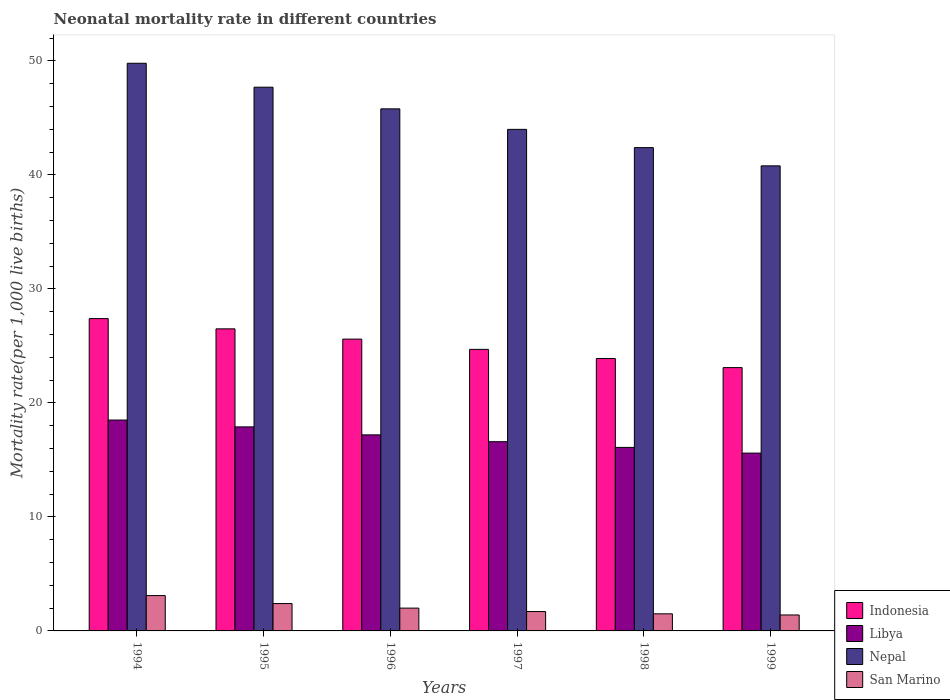How many different coloured bars are there?
Your response must be concise. 4. Are the number of bars per tick equal to the number of legend labels?
Ensure brevity in your answer.  Yes. How many bars are there on the 3rd tick from the left?
Keep it short and to the point. 4. What is the label of the 3rd group of bars from the left?
Your response must be concise. 1996. In how many cases, is the number of bars for a given year not equal to the number of legend labels?
Provide a succinct answer. 0. What is the neonatal mortality rate in Indonesia in 1998?
Offer a very short reply. 23.9. In which year was the neonatal mortality rate in Nepal maximum?
Your response must be concise. 1994. What is the total neonatal mortality rate in Indonesia in the graph?
Your answer should be very brief. 151.2. What is the difference between the neonatal mortality rate in San Marino in 1994 and that in 1995?
Keep it short and to the point. 0.7. What is the difference between the neonatal mortality rate in San Marino in 1997 and the neonatal mortality rate in Indonesia in 1999?
Offer a terse response. -21.4. What is the average neonatal mortality rate in San Marino per year?
Ensure brevity in your answer.  2.02. In the year 1998, what is the difference between the neonatal mortality rate in San Marino and neonatal mortality rate in Libya?
Your answer should be compact. -14.6. In how many years, is the neonatal mortality rate in Nepal greater than 44?
Give a very brief answer. 3. What is the ratio of the neonatal mortality rate in Nepal in 1994 to that in 1996?
Provide a short and direct response. 1.09. What is the difference between the highest and the second highest neonatal mortality rate in Indonesia?
Provide a succinct answer. 0.9. What is the difference between the highest and the lowest neonatal mortality rate in San Marino?
Offer a terse response. 1.7. What does the 4th bar from the left in 1998 represents?
Provide a short and direct response. San Marino. Is it the case that in every year, the sum of the neonatal mortality rate in Nepal and neonatal mortality rate in Indonesia is greater than the neonatal mortality rate in Libya?
Keep it short and to the point. Yes. Are all the bars in the graph horizontal?
Your answer should be very brief. No. Does the graph contain grids?
Provide a short and direct response. No. Where does the legend appear in the graph?
Ensure brevity in your answer.  Bottom right. What is the title of the graph?
Provide a short and direct response. Neonatal mortality rate in different countries. Does "Switzerland" appear as one of the legend labels in the graph?
Offer a very short reply. No. What is the label or title of the X-axis?
Offer a very short reply. Years. What is the label or title of the Y-axis?
Provide a succinct answer. Mortality rate(per 1,0 live births). What is the Mortality rate(per 1,000 live births) of Indonesia in 1994?
Your answer should be very brief. 27.4. What is the Mortality rate(per 1,000 live births) of Nepal in 1994?
Your response must be concise. 49.8. What is the Mortality rate(per 1,000 live births) of Libya in 1995?
Provide a succinct answer. 17.9. What is the Mortality rate(per 1,000 live births) in Nepal in 1995?
Provide a succinct answer. 47.7. What is the Mortality rate(per 1,000 live births) of San Marino in 1995?
Make the answer very short. 2.4. What is the Mortality rate(per 1,000 live births) in Indonesia in 1996?
Your answer should be very brief. 25.6. What is the Mortality rate(per 1,000 live births) of Libya in 1996?
Give a very brief answer. 17.2. What is the Mortality rate(per 1,000 live births) of Nepal in 1996?
Give a very brief answer. 45.8. What is the Mortality rate(per 1,000 live births) of San Marino in 1996?
Offer a terse response. 2. What is the Mortality rate(per 1,000 live births) in Indonesia in 1997?
Keep it short and to the point. 24.7. What is the Mortality rate(per 1,000 live births) in Nepal in 1997?
Your response must be concise. 44. What is the Mortality rate(per 1,000 live births) in San Marino in 1997?
Provide a succinct answer. 1.7. What is the Mortality rate(per 1,000 live births) of Indonesia in 1998?
Your response must be concise. 23.9. What is the Mortality rate(per 1,000 live births) in Nepal in 1998?
Give a very brief answer. 42.4. What is the Mortality rate(per 1,000 live births) in Indonesia in 1999?
Provide a short and direct response. 23.1. What is the Mortality rate(per 1,000 live births) of Libya in 1999?
Make the answer very short. 15.6. What is the Mortality rate(per 1,000 live births) of Nepal in 1999?
Ensure brevity in your answer.  40.8. Across all years, what is the maximum Mortality rate(per 1,000 live births) of Indonesia?
Offer a very short reply. 27.4. Across all years, what is the maximum Mortality rate(per 1,000 live births) of Libya?
Offer a very short reply. 18.5. Across all years, what is the maximum Mortality rate(per 1,000 live births) in Nepal?
Offer a very short reply. 49.8. Across all years, what is the minimum Mortality rate(per 1,000 live births) in Indonesia?
Ensure brevity in your answer.  23.1. Across all years, what is the minimum Mortality rate(per 1,000 live births) of Nepal?
Your response must be concise. 40.8. What is the total Mortality rate(per 1,000 live births) of Indonesia in the graph?
Provide a succinct answer. 151.2. What is the total Mortality rate(per 1,000 live births) of Libya in the graph?
Ensure brevity in your answer.  101.9. What is the total Mortality rate(per 1,000 live births) in Nepal in the graph?
Offer a very short reply. 270.5. What is the difference between the Mortality rate(per 1,000 live births) of Indonesia in 1994 and that in 1995?
Provide a short and direct response. 0.9. What is the difference between the Mortality rate(per 1,000 live births) of Libya in 1994 and that in 1995?
Offer a terse response. 0.6. What is the difference between the Mortality rate(per 1,000 live births) in San Marino in 1994 and that in 1996?
Offer a very short reply. 1.1. What is the difference between the Mortality rate(per 1,000 live births) of Indonesia in 1994 and that in 1997?
Your answer should be compact. 2.7. What is the difference between the Mortality rate(per 1,000 live births) of Nepal in 1994 and that in 1997?
Give a very brief answer. 5.8. What is the difference between the Mortality rate(per 1,000 live births) in Indonesia in 1994 and that in 1998?
Offer a very short reply. 3.5. What is the difference between the Mortality rate(per 1,000 live births) of Nepal in 1994 and that in 1998?
Your answer should be compact. 7.4. What is the difference between the Mortality rate(per 1,000 live births) of Libya in 1995 and that in 1996?
Provide a short and direct response. 0.7. What is the difference between the Mortality rate(per 1,000 live births) in Indonesia in 1995 and that in 1997?
Provide a short and direct response. 1.8. What is the difference between the Mortality rate(per 1,000 live births) in Indonesia in 1995 and that in 1998?
Your answer should be very brief. 2.6. What is the difference between the Mortality rate(per 1,000 live births) of Nepal in 1995 and that in 1998?
Keep it short and to the point. 5.3. What is the difference between the Mortality rate(per 1,000 live births) of San Marino in 1995 and that in 1998?
Provide a succinct answer. 0.9. What is the difference between the Mortality rate(per 1,000 live births) of Indonesia in 1995 and that in 1999?
Offer a terse response. 3.4. What is the difference between the Mortality rate(per 1,000 live births) of San Marino in 1995 and that in 1999?
Provide a succinct answer. 1. What is the difference between the Mortality rate(per 1,000 live births) in Libya in 1996 and that in 1997?
Offer a very short reply. 0.6. What is the difference between the Mortality rate(per 1,000 live births) of San Marino in 1996 and that in 1997?
Ensure brevity in your answer.  0.3. What is the difference between the Mortality rate(per 1,000 live births) of Indonesia in 1996 and that in 1998?
Your response must be concise. 1.7. What is the difference between the Mortality rate(per 1,000 live births) of Nepal in 1996 and that in 1998?
Ensure brevity in your answer.  3.4. What is the difference between the Mortality rate(per 1,000 live births) in San Marino in 1996 and that in 1998?
Your answer should be compact. 0.5. What is the difference between the Mortality rate(per 1,000 live births) in Indonesia in 1996 and that in 1999?
Ensure brevity in your answer.  2.5. What is the difference between the Mortality rate(per 1,000 live births) of Libya in 1996 and that in 1999?
Ensure brevity in your answer.  1.6. What is the difference between the Mortality rate(per 1,000 live births) of San Marino in 1996 and that in 1999?
Provide a short and direct response. 0.6. What is the difference between the Mortality rate(per 1,000 live births) of Libya in 1997 and that in 1998?
Offer a terse response. 0.5. What is the difference between the Mortality rate(per 1,000 live births) of Nepal in 1997 and that in 1998?
Make the answer very short. 1.6. What is the difference between the Mortality rate(per 1,000 live births) in Libya in 1997 and that in 1999?
Offer a terse response. 1. What is the difference between the Mortality rate(per 1,000 live births) in Nepal in 1997 and that in 1999?
Give a very brief answer. 3.2. What is the difference between the Mortality rate(per 1,000 live births) of San Marino in 1997 and that in 1999?
Your response must be concise. 0.3. What is the difference between the Mortality rate(per 1,000 live births) of Indonesia in 1998 and that in 1999?
Your answer should be compact. 0.8. What is the difference between the Mortality rate(per 1,000 live births) in Nepal in 1998 and that in 1999?
Ensure brevity in your answer.  1.6. What is the difference between the Mortality rate(per 1,000 live births) in San Marino in 1998 and that in 1999?
Provide a succinct answer. 0.1. What is the difference between the Mortality rate(per 1,000 live births) of Indonesia in 1994 and the Mortality rate(per 1,000 live births) of Libya in 1995?
Your response must be concise. 9.5. What is the difference between the Mortality rate(per 1,000 live births) of Indonesia in 1994 and the Mortality rate(per 1,000 live births) of Nepal in 1995?
Provide a short and direct response. -20.3. What is the difference between the Mortality rate(per 1,000 live births) in Indonesia in 1994 and the Mortality rate(per 1,000 live births) in San Marino in 1995?
Offer a very short reply. 25. What is the difference between the Mortality rate(per 1,000 live births) in Libya in 1994 and the Mortality rate(per 1,000 live births) in Nepal in 1995?
Ensure brevity in your answer.  -29.2. What is the difference between the Mortality rate(per 1,000 live births) in Nepal in 1994 and the Mortality rate(per 1,000 live births) in San Marino in 1995?
Make the answer very short. 47.4. What is the difference between the Mortality rate(per 1,000 live births) in Indonesia in 1994 and the Mortality rate(per 1,000 live births) in Nepal in 1996?
Offer a terse response. -18.4. What is the difference between the Mortality rate(per 1,000 live births) in Indonesia in 1994 and the Mortality rate(per 1,000 live births) in San Marino in 1996?
Your answer should be compact. 25.4. What is the difference between the Mortality rate(per 1,000 live births) in Libya in 1994 and the Mortality rate(per 1,000 live births) in Nepal in 1996?
Ensure brevity in your answer.  -27.3. What is the difference between the Mortality rate(per 1,000 live births) of Nepal in 1994 and the Mortality rate(per 1,000 live births) of San Marino in 1996?
Make the answer very short. 47.8. What is the difference between the Mortality rate(per 1,000 live births) in Indonesia in 1994 and the Mortality rate(per 1,000 live births) in Nepal in 1997?
Provide a short and direct response. -16.6. What is the difference between the Mortality rate(per 1,000 live births) in Indonesia in 1994 and the Mortality rate(per 1,000 live births) in San Marino in 1997?
Make the answer very short. 25.7. What is the difference between the Mortality rate(per 1,000 live births) of Libya in 1994 and the Mortality rate(per 1,000 live births) of Nepal in 1997?
Provide a short and direct response. -25.5. What is the difference between the Mortality rate(per 1,000 live births) of Nepal in 1994 and the Mortality rate(per 1,000 live births) of San Marino in 1997?
Give a very brief answer. 48.1. What is the difference between the Mortality rate(per 1,000 live births) of Indonesia in 1994 and the Mortality rate(per 1,000 live births) of Libya in 1998?
Provide a succinct answer. 11.3. What is the difference between the Mortality rate(per 1,000 live births) of Indonesia in 1994 and the Mortality rate(per 1,000 live births) of Nepal in 1998?
Provide a succinct answer. -15. What is the difference between the Mortality rate(per 1,000 live births) of Indonesia in 1994 and the Mortality rate(per 1,000 live births) of San Marino in 1998?
Make the answer very short. 25.9. What is the difference between the Mortality rate(per 1,000 live births) in Libya in 1994 and the Mortality rate(per 1,000 live births) in Nepal in 1998?
Keep it short and to the point. -23.9. What is the difference between the Mortality rate(per 1,000 live births) in Nepal in 1994 and the Mortality rate(per 1,000 live births) in San Marino in 1998?
Keep it short and to the point. 48.3. What is the difference between the Mortality rate(per 1,000 live births) of Indonesia in 1994 and the Mortality rate(per 1,000 live births) of Libya in 1999?
Your response must be concise. 11.8. What is the difference between the Mortality rate(per 1,000 live births) of Libya in 1994 and the Mortality rate(per 1,000 live births) of Nepal in 1999?
Your answer should be very brief. -22.3. What is the difference between the Mortality rate(per 1,000 live births) of Libya in 1994 and the Mortality rate(per 1,000 live births) of San Marino in 1999?
Give a very brief answer. 17.1. What is the difference between the Mortality rate(per 1,000 live births) in Nepal in 1994 and the Mortality rate(per 1,000 live births) in San Marino in 1999?
Make the answer very short. 48.4. What is the difference between the Mortality rate(per 1,000 live births) in Indonesia in 1995 and the Mortality rate(per 1,000 live births) in Libya in 1996?
Ensure brevity in your answer.  9.3. What is the difference between the Mortality rate(per 1,000 live births) in Indonesia in 1995 and the Mortality rate(per 1,000 live births) in Nepal in 1996?
Keep it short and to the point. -19.3. What is the difference between the Mortality rate(per 1,000 live births) of Libya in 1995 and the Mortality rate(per 1,000 live births) of Nepal in 1996?
Provide a short and direct response. -27.9. What is the difference between the Mortality rate(per 1,000 live births) in Libya in 1995 and the Mortality rate(per 1,000 live births) in San Marino in 1996?
Offer a terse response. 15.9. What is the difference between the Mortality rate(per 1,000 live births) in Nepal in 1995 and the Mortality rate(per 1,000 live births) in San Marino in 1996?
Offer a terse response. 45.7. What is the difference between the Mortality rate(per 1,000 live births) in Indonesia in 1995 and the Mortality rate(per 1,000 live births) in Nepal in 1997?
Keep it short and to the point. -17.5. What is the difference between the Mortality rate(per 1,000 live births) in Indonesia in 1995 and the Mortality rate(per 1,000 live births) in San Marino in 1997?
Your answer should be compact. 24.8. What is the difference between the Mortality rate(per 1,000 live births) in Libya in 1995 and the Mortality rate(per 1,000 live births) in Nepal in 1997?
Your answer should be compact. -26.1. What is the difference between the Mortality rate(per 1,000 live births) in Nepal in 1995 and the Mortality rate(per 1,000 live births) in San Marino in 1997?
Offer a terse response. 46. What is the difference between the Mortality rate(per 1,000 live births) of Indonesia in 1995 and the Mortality rate(per 1,000 live births) of Nepal in 1998?
Give a very brief answer. -15.9. What is the difference between the Mortality rate(per 1,000 live births) in Indonesia in 1995 and the Mortality rate(per 1,000 live births) in San Marino in 1998?
Provide a short and direct response. 25. What is the difference between the Mortality rate(per 1,000 live births) of Libya in 1995 and the Mortality rate(per 1,000 live births) of Nepal in 1998?
Ensure brevity in your answer.  -24.5. What is the difference between the Mortality rate(per 1,000 live births) of Libya in 1995 and the Mortality rate(per 1,000 live births) of San Marino in 1998?
Your response must be concise. 16.4. What is the difference between the Mortality rate(per 1,000 live births) in Nepal in 1995 and the Mortality rate(per 1,000 live births) in San Marino in 1998?
Offer a very short reply. 46.2. What is the difference between the Mortality rate(per 1,000 live births) of Indonesia in 1995 and the Mortality rate(per 1,000 live births) of Nepal in 1999?
Ensure brevity in your answer.  -14.3. What is the difference between the Mortality rate(per 1,000 live births) of Indonesia in 1995 and the Mortality rate(per 1,000 live births) of San Marino in 1999?
Provide a succinct answer. 25.1. What is the difference between the Mortality rate(per 1,000 live births) of Libya in 1995 and the Mortality rate(per 1,000 live births) of Nepal in 1999?
Keep it short and to the point. -22.9. What is the difference between the Mortality rate(per 1,000 live births) in Libya in 1995 and the Mortality rate(per 1,000 live births) in San Marino in 1999?
Provide a short and direct response. 16.5. What is the difference between the Mortality rate(per 1,000 live births) in Nepal in 1995 and the Mortality rate(per 1,000 live births) in San Marino in 1999?
Give a very brief answer. 46.3. What is the difference between the Mortality rate(per 1,000 live births) in Indonesia in 1996 and the Mortality rate(per 1,000 live births) in Nepal in 1997?
Your response must be concise. -18.4. What is the difference between the Mortality rate(per 1,000 live births) in Indonesia in 1996 and the Mortality rate(per 1,000 live births) in San Marino in 1997?
Your response must be concise. 23.9. What is the difference between the Mortality rate(per 1,000 live births) in Libya in 1996 and the Mortality rate(per 1,000 live births) in Nepal in 1997?
Your answer should be very brief. -26.8. What is the difference between the Mortality rate(per 1,000 live births) of Libya in 1996 and the Mortality rate(per 1,000 live births) of San Marino in 1997?
Your response must be concise. 15.5. What is the difference between the Mortality rate(per 1,000 live births) in Nepal in 1996 and the Mortality rate(per 1,000 live births) in San Marino in 1997?
Your answer should be compact. 44.1. What is the difference between the Mortality rate(per 1,000 live births) in Indonesia in 1996 and the Mortality rate(per 1,000 live births) in Nepal in 1998?
Offer a very short reply. -16.8. What is the difference between the Mortality rate(per 1,000 live births) of Indonesia in 1996 and the Mortality rate(per 1,000 live births) of San Marino in 1998?
Provide a short and direct response. 24.1. What is the difference between the Mortality rate(per 1,000 live births) in Libya in 1996 and the Mortality rate(per 1,000 live births) in Nepal in 1998?
Provide a succinct answer. -25.2. What is the difference between the Mortality rate(per 1,000 live births) in Libya in 1996 and the Mortality rate(per 1,000 live births) in San Marino in 1998?
Provide a succinct answer. 15.7. What is the difference between the Mortality rate(per 1,000 live births) of Nepal in 1996 and the Mortality rate(per 1,000 live births) of San Marino in 1998?
Give a very brief answer. 44.3. What is the difference between the Mortality rate(per 1,000 live births) of Indonesia in 1996 and the Mortality rate(per 1,000 live births) of Libya in 1999?
Offer a very short reply. 10. What is the difference between the Mortality rate(per 1,000 live births) of Indonesia in 1996 and the Mortality rate(per 1,000 live births) of Nepal in 1999?
Keep it short and to the point. -15.2. What is the difference between the Mortality rate(per 1,000 live births) in Indonesia in 1996 and the Mortality rate(per 1,000 live births) in San Marino in 1999?
Ensure brevity in your answer.  24.2. What is the difference between the Mortality rate(per 1,000 live births) of Libya in 1996 and the Mortality rate(per 1,000 live births) of Nepal in 1999?
Keep it short and to the point. -23.6. What is the difference between the Mortality rate(per 1,000 live births) in Libya in 1996 and the Mortality rate(per 1,000 live births) in San Marino in 1999?
Provide a succinct answer. 15.8. What is the difference between the Mortality rate(per 1,000 live births) in Nepal in 1996 and the Mortality rate(per 1,000 live births) in San Marino in 1999?
Your answer should be compact. 44.4. What is the difference between the Mortality rate(per 1,000 live births) in Indonesia in 1997 and the Mortality rate(per 1,000 live births) in Libya in 1998?
Offer a very short reply. 8.6. What is the difference between the Mortality rate(per 1,000 live births) of Indonesia in 1997 and the Mortality rate(per 1,000 live births) of Nepal in 1998?
Make the answer very short. -17.7. What is the difference between the Mortality rate(per 1,000 live births) of Indonesia in 1997 and the Mortality rate(per 1,000 live births) of San Marino in 1998?
Your answer should be very brief. 23.2. What is the difference between the Mortality rate(per 1,000 live births) of Libya in 1997 and the Mortality rate(per 1,000 live births) of Nepal in 1998?
Provide a succinct answer. -25.8. What is the difference between the Mortality rate(per 1,000 live births) of Libya in 1997 and the Mortality rate(per 1,000 live births) of San Marino in 1998?
Offer a terse response. 15.1. What is the difference between the Mortality rate(per 1,000 live births) in Nepal in 1997 and the Mortality rate(per 1,000 live births) in San Marino in 1998?
Provide a short and direct response. 42.5. What is the difference between the Mortality rate(per 1,000 live births) in Indonesia in 1997 and the Mortality rate(per 1,000 live births) in Nepal in 1999?
Provide a short and direct response. -16.1. What is the difference between the Mortality rate(per 1,000 live births) in Indonesia in 1997 and the Mortality rate(per 1,000 live births) in San Marino in 1999?
Give a very brief answer. 23.3. What is the difference between the Mortality rate(per 1,000 live births) in Libya in 1997 and the Mortality rate(per 1,000 live births) in Nepal in 1999?
Your response must be concise. -24.2. What is the difference between the Mortality rate(per 1,000 live births) in Nepal in 1997 and the Mortality rate(per 1,000 live births) in San Marino in 1999?
Offer a very short reply. 42.6. What is the difference between the Mortality rate(per 1,000 live births) in Indonesia in 1998 and the Mortality rate(per 1,000 live births) in Nepal in 1999?
Give a very brief answer. -16.9. What is the difference between the Mortality rate(per 1,000 live births) of Indonesia in 1998 and the Mortality rate(per 1,000 live births) of San Marino in 1999?
Offer a very short reply. 22.5. What is the difference between the Mortality rate(per 1,000 live births) in Libya in 1998 and the Mortality rate(per 1,000 live births) in Nepal in 1999?
Provide a short and direct response. -24.7. What is the difference between the Mortality rate(per 1,000 live births) in Libya in 1998 and the Mortality rate(per 1,000 live births) in San Marino in 1999?
Offer a very short reply. 14.7. What is the difference between the Mortality rate(per 1,000 live births) of Nepal in 1998 and the Mortality rate(per 1,000 live births) of San Marino in 1999?
Ensure brevity in your answer.  41. What is the average Mortality rate(per 1,000 live births) of Indonesia per year?
Provide a succinct answer. 25.2. What is the average Mortality rate(per 1,000 live births) in Libya per year?
Give a very brief answer. 16.98. What is the average Mortality rate(per 1,000 live births) of Nepal per year?
Your answer should be compact. 45.08. What is the average Mortality rate(per 1,000 live births) in San Marino per year?
Offer a very short reply. 2.02. In the year 1994, what is the difference between the Mortality rate(per 1,000 live births) of Indonesia and Mortality rate(per 1,000 live births) of Nepal?
Provide a short and direct response. -22.4. In the year 1994, what is the difference between the Mortality rate(per 1,000 live births) of Indonesia and Mortality rate(per 1,000 live births) of San Marino?
Provide a short and direct response. 24.3. In the year 1994, what is the difference between the Mortality rate(per 1,000 live births) in Libya and Mortality rate(per 1,000 live births) in Nepal?
Offer a very short reply. -31.3. In the year 1994, what is the difference between the Mortality rate(per 1,000 live births) of Libya and Mortality rate(per 1,000 live births) of San Marino?
Offer a very short reply. 15.4. In the year 1994, what is the difference between the Mortality rate(per 1,000 live births) in Nepal and Mortality rate(per 1,000 live births) in San Marino?
Offer a very short reply. 46.7. In the year 1995, what is the difference between the Mortality rate(per 1,000 live births) in Indonesia and Mortality rate(per 1,000 live births) in Nepal?
Offer a terse response. -21.2. In the year 1995, what is the difference between the Mortality rate(per 1,000 live births) of Indonesia and Mortality rate(per 1,000 live births) of San Marino?
Offer a terse response. 24.1. In the year 1995, what is the difference between the Mortality rate(per 1,000 live births) in Libya and Mortality rate(per 1,000 live births) in Nepal?
Offer a terse response. -29.8. In the year 1995, what is the difference between the Mortality rate(per 1,000 live births) of Nepal and Mortality rate(per 1,000 live births) of San Marino?
Ensure brevity in your answer.  45.3. In the year 1996, what is the difference between the Mortality rate(per 1,000 live births) of Indonesia and Mortality rate(per 1,000 live births) of Libya?
Your response must be concise. 8.4. In the year 1996, what is the difference between the Mortality rate(per 1,000 live births) of Indonesia and Mortality rate(per 1,000 live births) of Nepal?
Offer a terse response. -20.2. In the year 1996, what is the difference between the Mortality rate(per 1,000 live births) of Indonesia and Mortality rate(per 1,000 live births) of San Marino?
Your answer should be compact. 23.6. In the year 1996, what is the difference between the Mortality rate(per 1,000 live births) of Libya and Mortality rate(per 1,000 live births) of Nepal?
Make the answer very short. -28.6. In the year 1996, what is the difference between the Mortality rate(per 1,000 live births) of Nepal and Mortality rate(per 1,000 live births) of San Marino?
Your response must be concise. 43.8. In the year 1997, what is the difference between the Mortality rate(per 1,000 live births) in Indonesia and Mortality rate(per 1,000 live births) in Libya?
Give a very brief answer. 8.1. In the year 1997, what is the difference between the Mortality rate(per 1,000 live births) in Indonesia and Mortality rate(per 1,000 live births) in Nepal?
Offer a terse response. -19.3. In the year 1997, what is the difference between the Mortality rate(per 1,000 live births) in Indonesia and Mortality rate(per 1,000 live births) in San Marino?
Offer a terse response. 23. In the year 1997, what is the difference between the Mortality rate(per 1,000 live births) in Libya and Mortality rate(per 1,000 live births) in Nepal?
Your answer should be compact. -27.4. In the year 1997, what is the difference between the Mortality rate(per 1,000 live births) in Libya and Mortality rate(per 1,000 live births) in San Marino?
Provide a succinct answer. 14.9. In the year 1997, what is the difference between the Mortality rate(per 1,000 live births) in Nepal and Mortality rate(per 1,000 live births) in San Marino?
Offer a terse response. 42.3. In the year 1998, what is the difference between the Mortality rate(per 1,000 live births) of Indonesia and Mortality rate(per 1,000 live births) of Nepal?
Your answer should be compact. -18.5. In the year 1998, what is the difference between the Mortality rate(per 1,000 live births) of Indonesia and Mortality rate(per 1,000 live births) of San Marino?
Provide a succinct answer. 22.4. In the year 1998, what is the difference between the Mortality rate(per 1,000 live births) in Libya and Mortality rate(per 1,000 live births) in Nepal?
Your answer should be compact. -26.3. In the year 1998, what is the difference between the Mortality rate(per 1,000 live births) in Nepal and Mortality rate(per 1,000 live births) in San Marino?
Give a very brief answer. 40.9. In the year 1999, what is the difference between the Mortality rate(per 1,000 live births) of Indonesia and Mortality rate(per 1,000 live births) of Libya?
Provide a short and direct response. 7.5. In the year 1999, what is the difference between the Mortality rate(per 1,000 live births) of Indonesia and Mortality rate(per 1,000 live births) of Nepal?
Your answer should be compact. -17.7. In the year 1999, what is the difference between the Mortality rate(per 1,000 live births) in Indonesia and Mortality rate(per 1,000 live births) in San Marino?
Ensure brevity in your answer.  21.7. In the year 1999, what is the difference between the Mortality rate(per 1,000 live births) of Libya and Mortality rate(per 1,000 live births) of Nepal?
Provide a short and direct response. -25.2. In the year 1999, what is the difference between the Mortality rate(per 1,000 live births) in Nepal and Mortality rate(per 1,000 live births) in San Marino?
Your response must be concise. 39.4. What is the ratio of the Mortality rate(per 1,000 live births) in Indonesia in 1994 to that in 1995?
Your response must be concise. 1.03. What is the ratio of the Mortality rate(per 1,000 live births) of Libya in 1994 to that in 1995?
Give a very brief answer. 1.03. What is the ratio of the Mortality rate(per 1,000 live births) in Nepal in 1994 to that in 1995?
Ensure brevity in your answer.  1.04. What is the ratio of the Mortality rate(per 1,000 live births) in San Marino in 1994 to that in 1995?
Make the answer very short. 1.29. What is the ratio of the Mortality rate(per 1,000 live births) of Indonesia in 1994 to that in 1996?
Provide a succinct answer. 1.07. What is the ratio of the Mortality rate(per 1,000 live births) of Libya in 1994 to that in 1996?
Offer a very short reply. 1.08. What is the ratio of the Mortality rate(per 1,000 live births) in Nepal in 1994 to that in 1996?
Ensure brevity in your answer.  1.09. What is the ratio of the Mortality rate(per 1,000 live births) of San Marino in 1994 to that in 1996?
Your answer should be very brief. 1.55. What is the ratio of the Mortality rate(per 1,000 live births) of Indonesia in 1994 to that in 1997?
Provide a succinct answer. 1.11. What is the ratio of the Mortality rate(per 1,000 live births) of Libya in 1994 to that in 1997?
Provide a succinct answer. 1.11. What is the ratio of the Mortality rate(per 1,000 live births) of Nepal in 1994 to that in 1997?
Make the answer very short. 1.13. What is the ratio of the Mortality rate(per 1,000 live births) in San Marino in 1994 to that in 1997?
Offer a very short reply. 1.82. What is the ratio of the Mortality rate(per 1,000 live births) of Indonesia in 1994 to that in 1998?
Your answer should be compact. 1.15. What is the ratio of the Mortality rate(per 1,000 live births) in Libya in 1994 to that in 1998?
Provide a succinct answer. 1.15. What is the ratio of the Mortality rate(per 1,000 live births) in Nepal in 1994 to that in 1998?
Provide a succinct answer. 1.17. What is the ratio of the Mortality rate(per 1,000 live births) of San Marino in 1994 to that in 1998?
Keep it short and to the point. 2.07. What is the ratio of the Mortality rate(per 1,000 live births) of Indonesia in 1994 to that in 1999?
Offer a terse response. 1.19. What is the ratio of the Mortality rate(per 1,000 live births) of Libya in 1994 to that in 1999?
Ensure brevity in your answer.  1.19. What is the ratio of the Mortality rate(per 1,000 live births) in Nepal in 1994 to that in 1999?
Provide a short and direct response. 1.22. What is the ratio of the Mortality rate(per 1,000 live births) of San Marino in 1994 to that in 1999?
Provide a succinct answer. 2.21. What is the ratio of the Mortality rate(per 1,000 live births) in Indonesia in 1995 to that in 1996?
Offer a very short reply. 1.04. What is the ratio of the Mortality rate(per 1,000 live births) in Libya in 1995 to that in 1996?
Ensure brevity in your answer.  1.04. What is the ratio of the Mortality rate(per 1,000 live births) of Nepal in 1995 to that in 1996?
Provide a succinct answer. 1.04. What is the ratio of the Mortality rate(per 1,000 live births) of Indonesia in 1995 to that in 1997?
Keep it short and to the point. 1.07. What is the ratio of the Mortality rate(per 1,000 live births) of Libya in 1995 to that in 1997?
Offer a terse response. 1.08. What is the ratio of the Mortality rate(per 1,000 live births) in Nepal in 1995 to that in 1997?
Provide a short and direct response. 1.08. What is the ratio of the Mortality rate(per 1,000 live births) of San Marino in 1995 to that in 1997?
Your answer should be very brief. 1.41. What is the ratio of the Mortality rate(per 1,000 live births) of Indonesia in 1995 to that in 1998?
Provide a short and direct response. 1.11. What is the ratio of the Mortality rate(per 1,000 live births) in Libya in 1995 to that in 1998?
Your answer should be compact. 1.11. What is the ratio of the Mortality rate(per 1,000 live births) of San Marino in 1995 to that in 1998?
Ensure brevity in your answer.  1.6. What is the ratio of the Mortality rate(per 1,000 live births) in Indonesia in 1995 to that in 1999?
Your response must be concise. 1.15. What is the ratio of the Mortality rate(per 1,000 live births) in Libya in 1995 to that in 1999?
Make the answer very short. 1.15. What is the ratio of the Mortality rate(per 1,000 live births) of Nepal in 1995 to that in 1999?
Provide a succinct answer. 1.17. What is the ratio of the Mortality rate(per 1,000 live births) of San Marino in 1995 to that in 1999?
Your answer should be compact. 1.71. What is the ratio of the Mortality rate(per 1,000 live births) of Indonesia in 1996 to that in 1997?
Your answer should be compact. 1.04. What is the ratio of the Mortality rate(per 1,000 live births) of Libya in 1996 to that in 1997?
Your response must be concise. 1.04. What is the ratio of the Mortality rate(per 1,000 live births) of Nepal in 1996 to that in 1997?
Offer a very short reply. 1.04. What is the ratio of the Mortality rate(per 1,000 live births) in San Marino in 1996 to that in 1997?
Keep it short and to the point. 1.18. What is the ratio of the Mortality rate(per 1,000 live births) of Indonesia in 1996 to that in 1998?
Give a very brief answer. 1.07. What is the ratio of the Mortality rate(per 1,000 live births) in Libya in 1996 to that in 1998?
Your answer should be compact. 1.07. What is the ratio of the Mortality rate(per 1,000 live births) of Nepal in 1996 to that in 1998?
Provide a short and direct response. 1.08. What is the ratio of the Mortality rate(per 1,000 live births) in San Marino in 1996 to that in 1998?
Offer a very short reply. 1.33. What is the ratio of the Mortality rate(per 1,000 live births) in Indonesia in 1996 to that in 1999?
Keep it short and to the point. 1.11. What is the ratio of the Mortality rate(per 1,000 live births) in Libya in 1996 to that in 1999?
Ensure brevity in your answer.  1.1. What is the ratio of the Mortality rate(per 1,000 live births) in Nepal in 1996 to that in 1999?
Your answer should be very brief. 1.12. What is the ratio of the Mortality rate(per 1,000 live births) in San Marino in 1996 to that in 1999?
Your answer should be compact. 1.43. What is the ratio of the Mortality rate(per 1,000 live births) of Indonesia in 1997 to that in 1998?
Keep it short and to the point. 1.03. What is the ratio of the Mortality rate(per 1,000 live births) in Libya in 1997 to that in 1998?
Keep it short and to the point. 1.03. What is the ratio of the Mortality rate(per 1,000 live births) in Nepal in 1997 to that in 1998?
Offer a terse response. 1.04. What is the ratio of the Mortality rate(per 1,000 live births) of San Marino in 1997 to that in 1998?
Your response must be concise. 1.13. What is the ratio of the Mortality rate(per 1,000 live births) in Indonesia in 1997 to that in 1999?
Give a very brief answer. 1.07. What is the ratio of the Mortality rate(per 1,000 live births) in Libya in 1997 to that in 1999?
Your answer should be very brief. 1.06. What is the ratio of the Mortality rate(per 1,000 live births) of Nepal in 1997 to that in 1999?
Your answer should be compact. 1.08. What is the ratio of the Mortality rate(per 1,000 live births) of San Marino in 1997 to that in 1999?
Ensure brevity in your answer.  1.21. What is the ratio of the Mortality rate(per 1,000 live births) in Indonesia in 1998 to that in 1999?
Provide a short and direct response. 1.03. What is the ratio of the Mortality rate(per 1,000 live births) of Libya in 1998 to that in 1999?
Give a very brief answer. 1.03. What is the ratio of the Mortality rate(per 1,000 live births) of Nepal in 1998 to that in 1999?
Your response must be concise. 1.04. What is the ratio of the Mortality rate(per 1,000 live births) in San Marino in 1998 to that in 1999?
Offer a terse response. 1.07. What is the difference between the highest and the second highest Mortality rate(per 1,000 live births) of Indonesia?
Your answer should be compact. 0.9. What is the difference between the highest and the second highest Mortality rate(per 1,000 live births) in Libya?
Offer a terse response. 0.6. What is the difference between the highest and the second highest Mortality rate(per 1,000 live births) in Nepal?
Give a very brief answer. 2.1. What is the difference between the highest and the second highest Mortality rate(per 1,000 live births) in San Marino?
Give a very brief answer. 0.7. What is the difference between the highest and the lowest Mortality rate(per 1,000 live births) in Indonesia?
Provide a short and direct response. 4.3. What is the difference between the highest and the lowest Mortality rate(per 1,000 live births) in Nepal?
Make the answer very short. 9. 